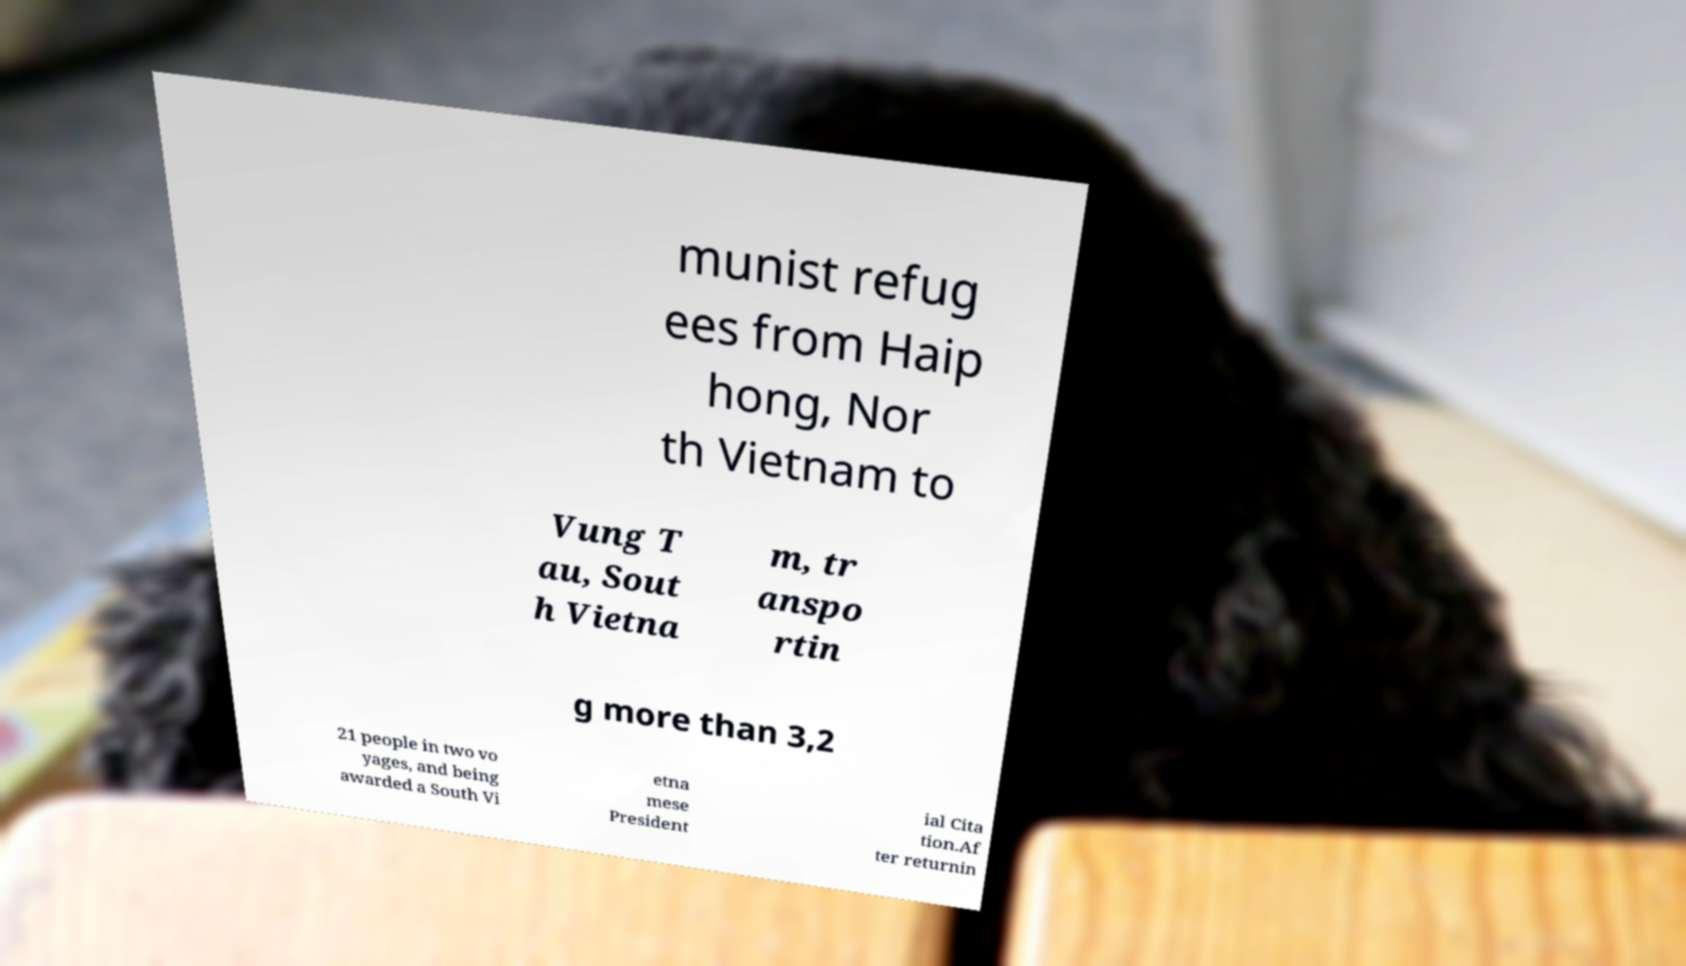For documentation purposes, I need the text within this image transcribed. Could you provide that? munist refug ees from Haip hong, Nor th Vietnam to Vung T au, Sout h Vietna m, tr anspo rtin g more than 3,2 21 people in two vo yages, and being awarded a South Vi etna mese President ial Cita tion.Af ter returnin 